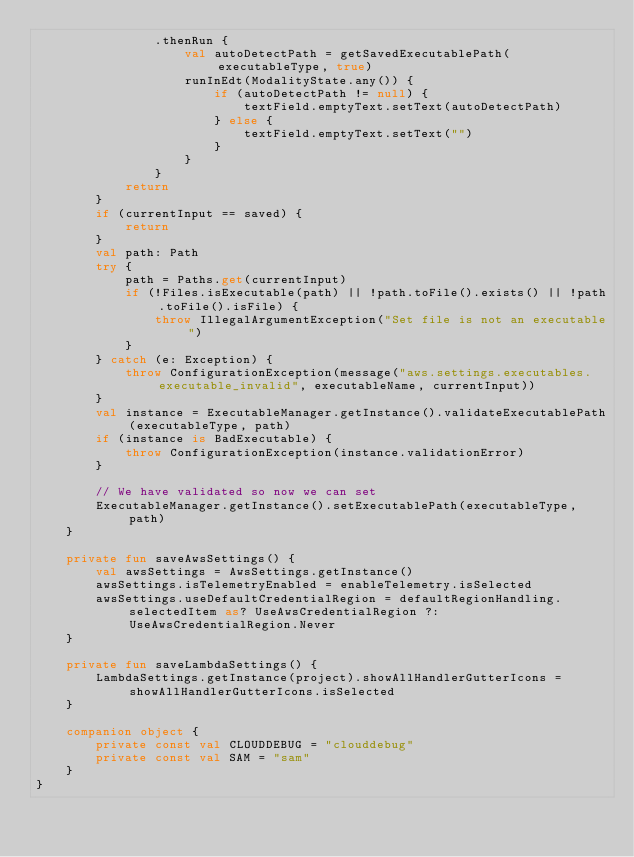Convert code to text. <code><loc_0><loc_0><loc_500><loc_500><_Kotlin_>                .thenRun {
                    val autoDetectPath = getSavedExecutablePath(executableType, true)
                    runInEdt(ModalityState.any()) {
                        if (autoDetectPath != null) {
                            textField.emptyText.setText(autoDetectPath)
                        } else {
                            textField.emptyText.setText("")
                        }
                    }
                }
            return
        }
        if (currentInput == saved) {
            return
        }
        val path: Path
        try {
            path = Paths.get(currentInput)
            if (!Files.isExecutable(path) || !path.toFile().exists() || !path.toFile().isFile) {
                throw IllegalArgumentException("Set file is not an executable")
            }
        } catch (e: Exception) {
            throw ConfigurationException(message("aws.settings.executables.executable_invalid", executableName, currentInput))
        }
        val instance = ExecutableManager.getInstance().validateExecutablePath(executableType, path)
        if (instance is BadExecutable) {
            throw ConfigurationException(instance.validationError)
        }

        // We have validated so now we can set
        ExecutableManager.getInstance().setExecutablePath(executableType, path)
    }

    private fun saveAwsSettings() {
        val awsSettings = AwsSettings.getInstance()
        awsSettings.isTelemetryEnabled = enableTelemetry.isSelected
        awsSettings.useDefaultCredentialRegion = defaultRegionHandling.selectedItem as? UseAwsCredentialRegion ?: UseAwsCredentialRegion.Never
    }

    private fun saveLambdaSettings() {
        LambdaSettings.getInstance(project).showAllHandlerGutterIcons = showAllHandlerGutterIcons.isSelected
    }

    companion object {
        private const val CLOUDDEBUG = "clouddebug"
        private const val SAM = "sam"
    }
}
</code> 